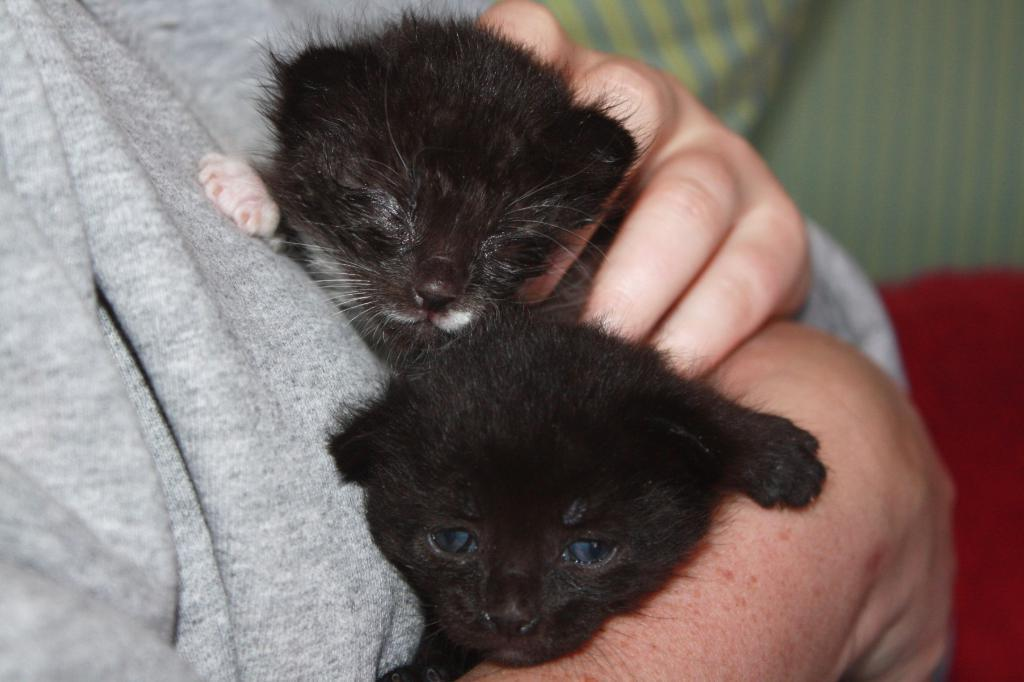What is the main subject of the image? There is a person in the image. What is the person wearing? The person is wearing a gray t-shirt. What is the person holding in the image? The person is holding two cats. What can be seen in the background of the image? There are clothes in the background of the image. What colors are the clothes in the background? The clothes are in red and green colors. What type of brass instrument is the person playing in the image? There is no brass instrument present in the image; the person is holding two cats. 